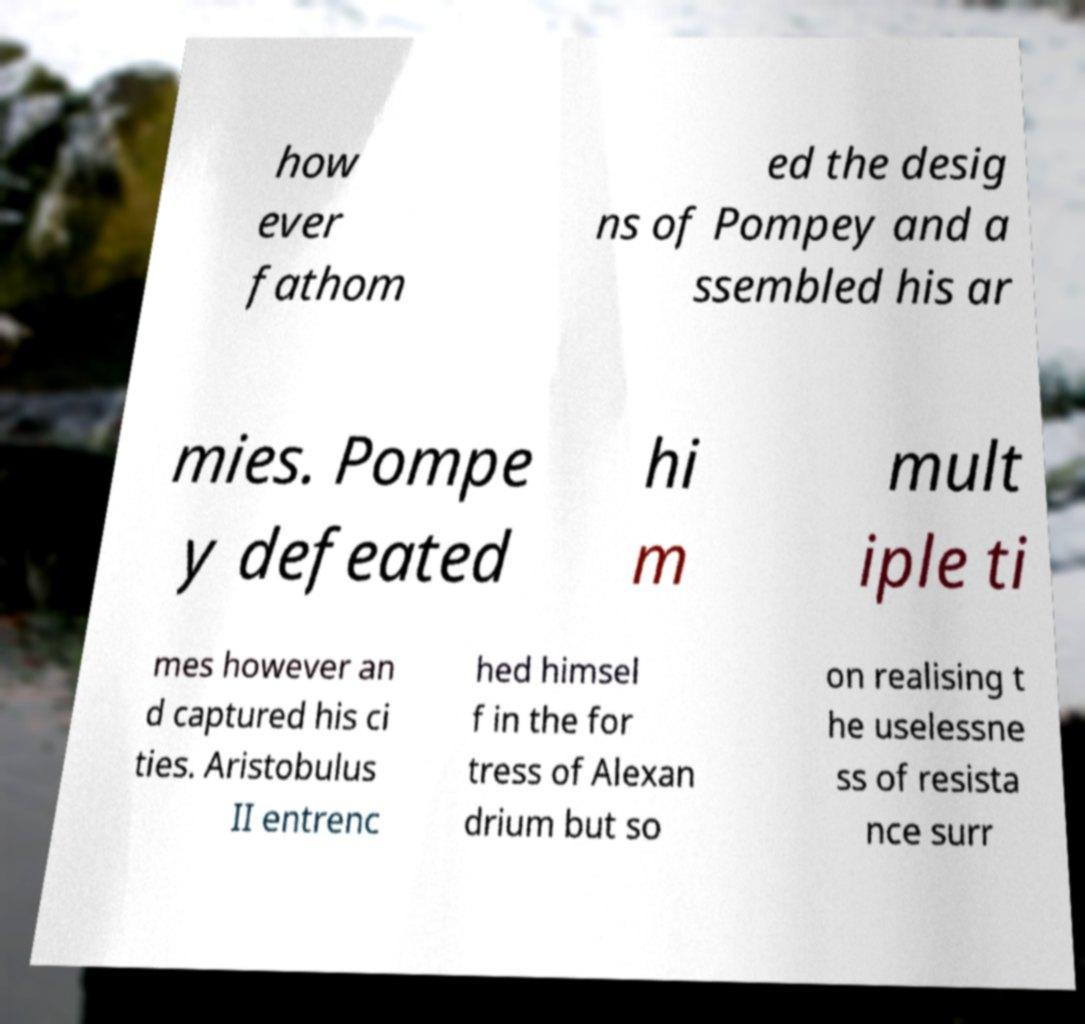What messages or text are displayed in this image? I need them in a readable, typed format. how ever fathom ed the desig ns of Pompey and a ssembled his ar mies. Pompe y defeated hi m mult iple ti mes however an d captured his ci ties. Aristobulus II entrenc hed himsel f in the for tress of Alexan drium but so on realising t he uselessne ss of resista nce surr 